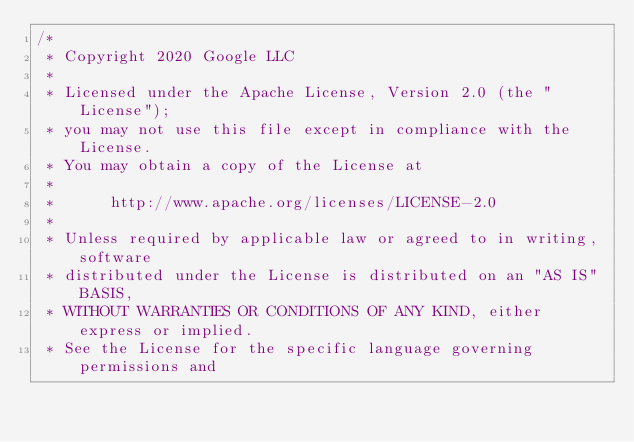Convert code to text. <code><loc_0><loc_0><loc_500><loc_500><_C++_>/*
 * Copyright 2020 Google LLC
 *
 * Licensed under the Apache License, Version 2.0 (the "License");
 * you may not use this file except in compliance with the License.
 * You may obtain a copy of the License at
 *
 *      http://www.apache.org/licenses/LICENSE-2.0
 *
 * Unless required by applicable law or agreed to in writing, software
 * distributed under the License is distributed on an "AS IS" BASIS,
 * WITHOUT WARRANTIES OR CONDITIONS OF ANY KIND, either express or implied.
 * See the License for the specific language governing permissions and</code> 